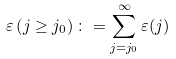<formula> <loc_0><loc_0><loc_500><loc_500>\varepsilon \left ( j \geq j _ { 0 } \right ) \colon = \sum ^ { \infty } _ { j = j _ { 0 } } \varepsilon ( j )</formula> 